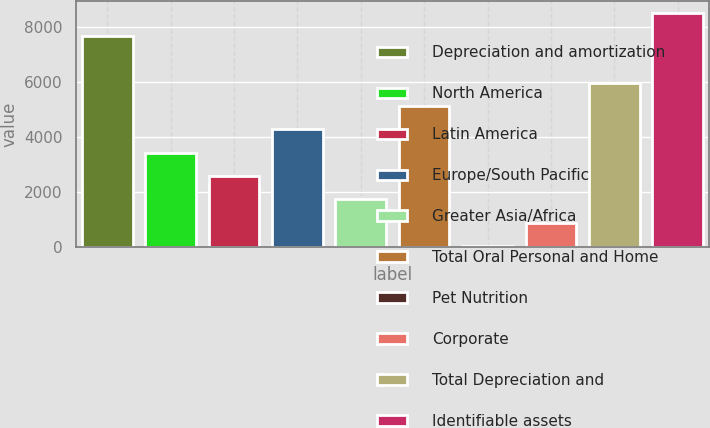Convert chart to OTSL. <chart><loc_0><loc_0><loc_500><loc_500><bar_chart><fcel>Depreciation and amortization<fcel>North America<fcel>Latin America<fcel>Europe/South Pacific<fcel>Greater Asia/Africa<fcel>Total Oral Personal and Home<fcel>Pet Nutrition<fcel>Corporate<fcel>Total Depreciation and<fcel>Identifiable assets<nl><fcel>7659.4<fcel>3420.9<fcel>2573.2<fcel>4268.6<fcel>1725.5<fcel>5116.3<fcel>30.1<fcel>877.8<fcel>5964<fcel>8507.1<nl></chart> 